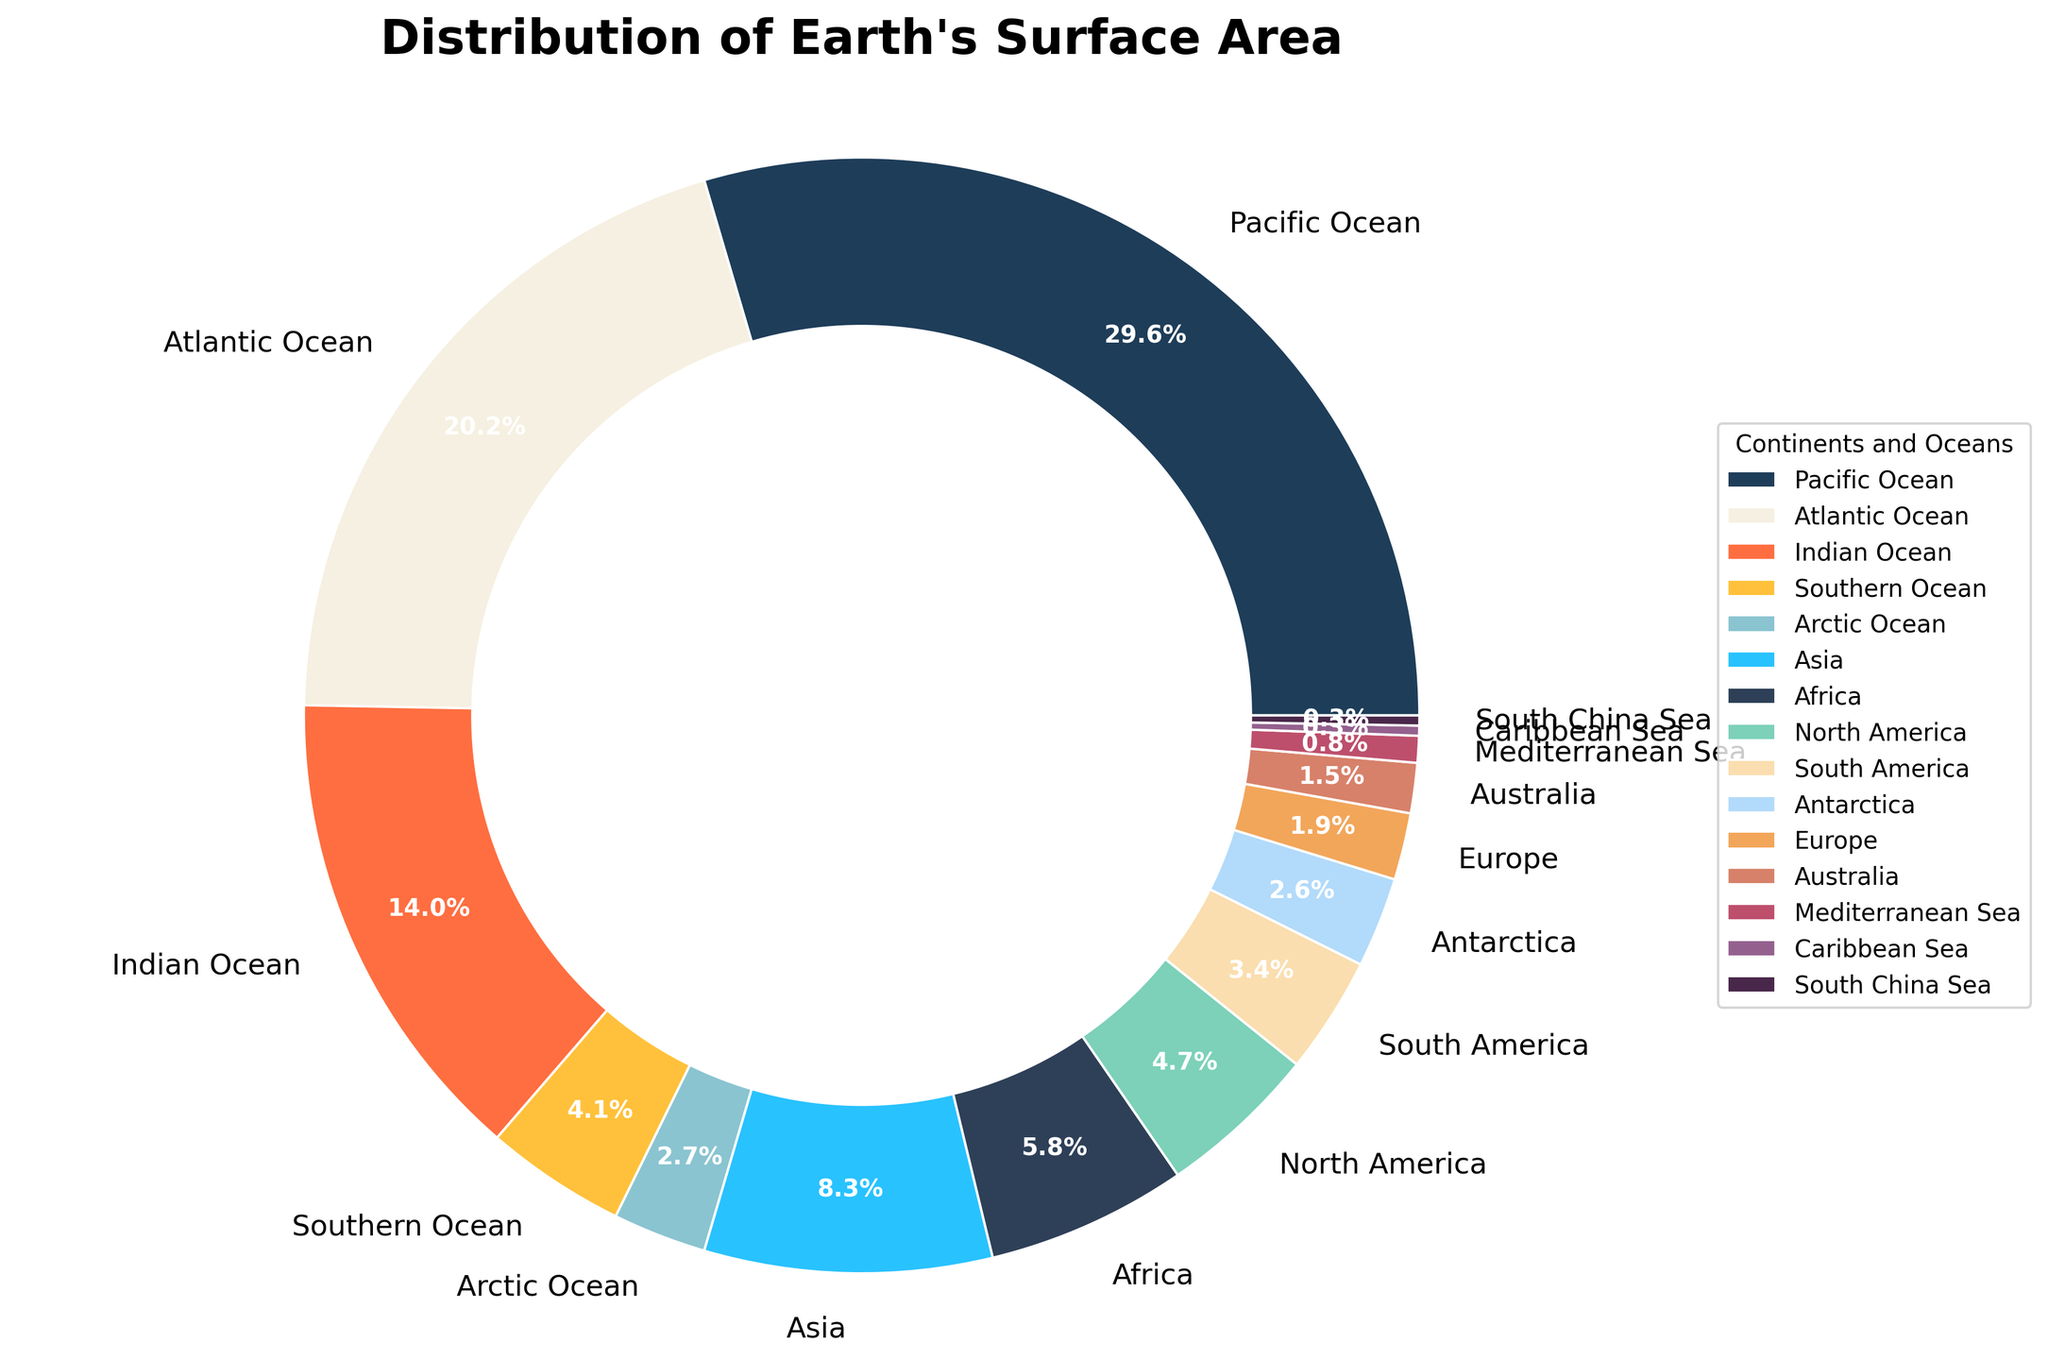Which continent or ocean has the largest surface area percentage? The segment with the largest proportion should be identified. According to the pie chart, the Pacific Ocean occupies the largest segment with 30.5%.
Answer: Pacific Ocean Which ocean has the least surface area percentage, and what is that percentage? Look for the smallest segment within the oceans. The Arctic Ocean is the smallest ocean segment with 2.8%.
Answer: Arctic Ocean, 2.8% What is the combined percentage of surface area for all the oceans? Sum the percentages for the Pacific Ocean, Atlantic Ocean, Indian Ocean, Southern Ocean, and Arctic Ocean. Summing them up: 30.5 + 20.8 + 14.4 + 4.2 + 2.8 = 72.7%.
Answer: 72.7% Is Asia’s surface area larger or smaller than Antarctica’s? Compare the percentages of Asia and Antarctica. Asia has 8.6%, and Antarctica has 2.7%.
Answer: Larger Which has a larger surface area percentage: Europe or Australia, and by how much? Compare the percentages of Europe and Australia. Europe has 2.0%, and Australia has 1.5%. The difference is 2.0% - 1.5% = 0.5%.
Answer: Europe, 0.5% What is the difference in surface area percentage between North America and South America? Subtract the percentage of South America from North America. North America has 4.8%, and South America has 3.5%. The difference is 4.8% - 3.5% = 1.3%.
Answer: 1.3% Which geographical feature has the smallest surface area percentage? Identify the smallest segment overall. The Caribbean Sea and South China Sea both have the smallest segment with 0.3%.
Answer: Caribbean Sea and South China Sea What is the combined percentage of surface area for all the continents? Sum the percentages for Asia, Africa, North America, South America, Antarctica, Europe, and Australia. Summing them up: 8.6 + 6.0 + 4.8 + 3.5 + 2.7 + 2.0 + 1.5 = 29.1%.
Answer: 29.1% Between the Southern Ocean and the Mediterranean Sea, which has a greater surface area percentage and by how much? Compare their percentages. The Southern Ocean has 4.2%, while the Mediterranean Sea has 0.8%. The difference is 4.2% - 0.8% = 3.4%.
Answer: Southern Ocean, 3.4% What’s the combined surface area percentage of the Mediterranean Sea and the South China Sea? Sum their percentages. Mediterranean Sea is 0.8%, and South China Sea is 0.3%. 0.8 + 0.3 = 1.1%.
Answer: 1.1% 